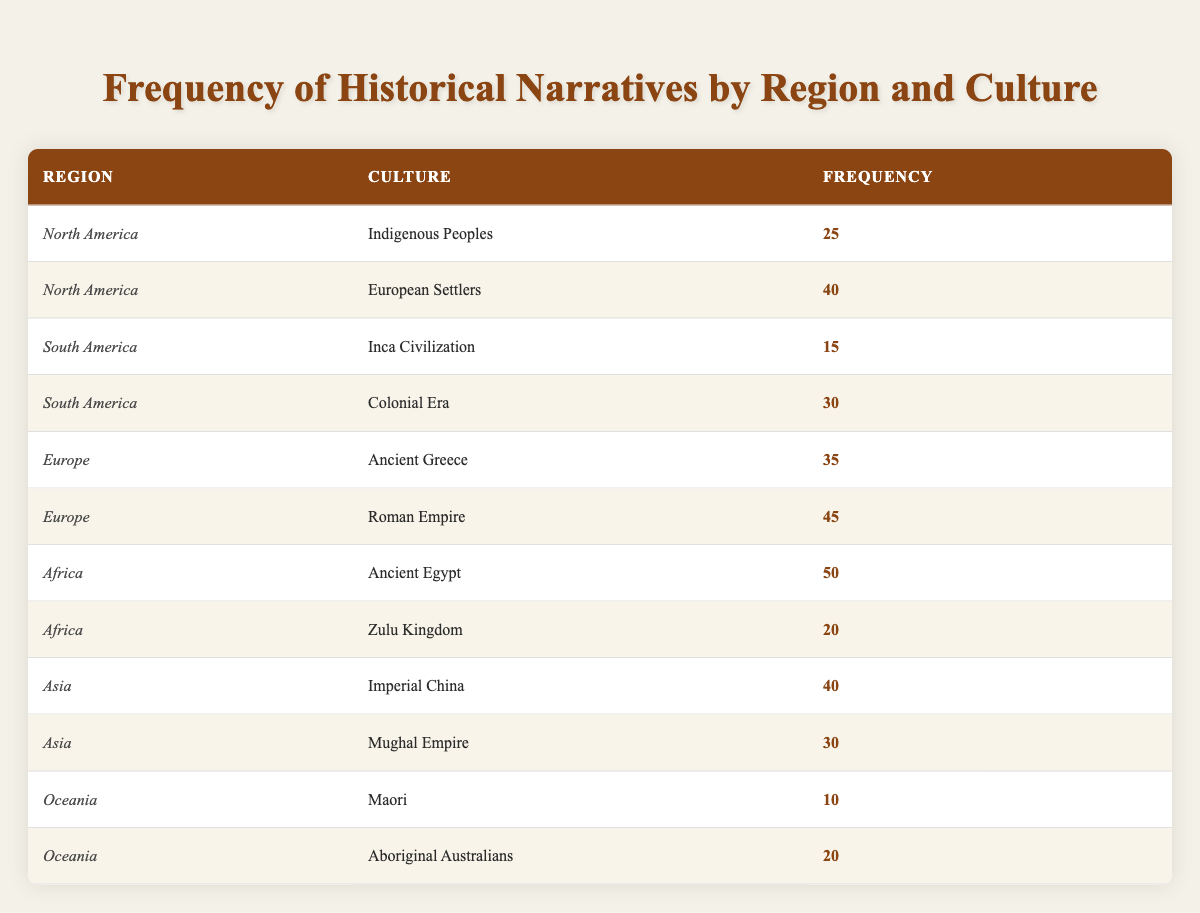What is the frequency of historical narratives for Indigenous Peoples in North America? The table shows that the frequency for Indigenous Peoples under the North America region is 25.
Answer: 25 Which region has the highest total frequency of historical narratives? To find the region with the highest total frequency, sum the frequencies for each region: North America (25 + 40 = 65), South America (15 + 30 = 45), Europe (35 + 45 = 80), Africa (50 + 20 = 70), Asia (40 + 30 = 70), Oceania (10 + 20 = 30). The highest total is for Europe with a frequency of 80.
Answer: Europe Is there a historical narrative for the Mughal Empire in the collection? The table lists the Mughal Empire under the Asia region with a frequency of 30, confirming that there is a historical narrative for it.
Answer: Yes What is the combined frequency of historical narratives from South America? The combined frequency for South America is calculated by adding the frequencies of Inca Civilization (15) and Colonial Era (30): 15 + 30 = 45.
Answer: 45 Which culture has the lowest frequency of historical narratives in Oceania? The frequency for Maori is 10, and for Aboriginal Australians, it is 20. Therefore, Maori has the lowest frequency in Oceania.
Answer: Maori In which region is the Roman Empire culture located and what is its frequency? The Roman Empire is located in Europe, and its frequency is stated as 45 in the table.
Answer: Europe, 45 What is the difference in frequency between the Ancient Egypt culture and the Indigenous Peoples culture? The frequency of Ancient Egypt is 50, and that of Indigenous Peoples is 25. The difference is computed as 50 - 25 = 25.
Answer: 25 What proportion of total historical narratives does the Zulu Kingdom account for in Africa? The total frequency for Africa is 70 (Ancient Egypt 50 + Zulu Kingdom 20). The frequency for Zulu Kingdom is 20. The proportion is calculated as 20/70, approximately 0.286, or 28.6%.
Answer: 28.6% How many cultures from Europe are represented in the collection? The table lists two cultures from Europe: Ancient Greece and Roman Empire. Thus, there are two cultures represented.
Answer: 2 